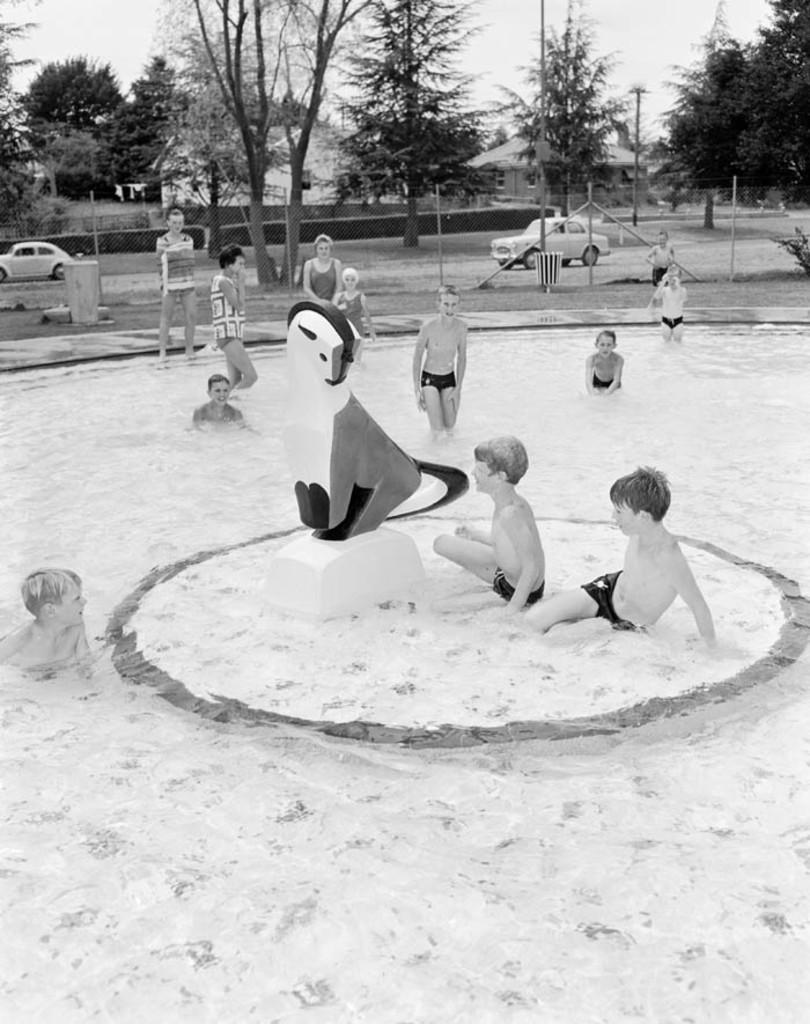What are the people in the image doing? The persons in the image are in the water in the center of the image. What can be seen in the background of the image? Cars are moving on the road, and there are trees, buildings, and plants in the background. What type of sweater is being worn by the plants in the image? There are no sweaters present in the image, as the plants are not wearing any clothing. 